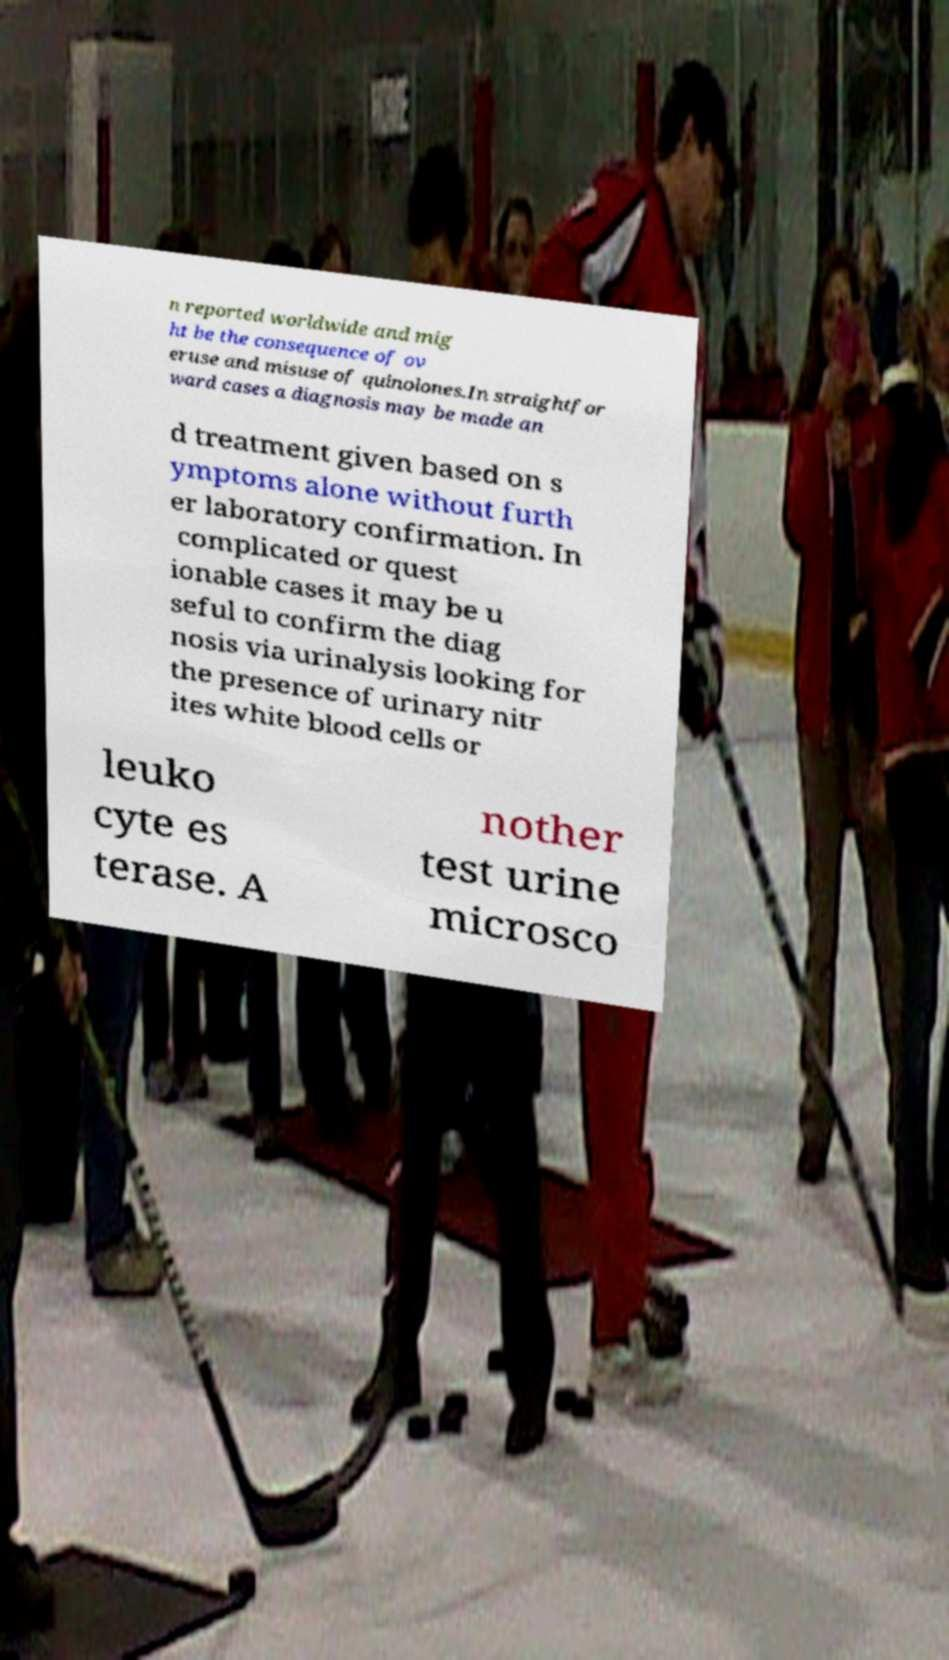Please identify and transcribe the text found in this image. n reported worldwide and mig ht be the consequence of ov eruse and misuse of quinolones.In straightfor ward cases a diagnosis may be made an d treatment given based on s ymptoms alone without furth er laboratory confirmation. In complicated or quest ionable cases it may be u seful to confirm the diag nosis via urinalysis looking for the presence of urinary nitr ites white blood cells or leuko cyte es terase. A nother test urine microsco 